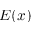<formula> <loc_0><loc_0><loc_500><loc_500>E ( x )</formula> 